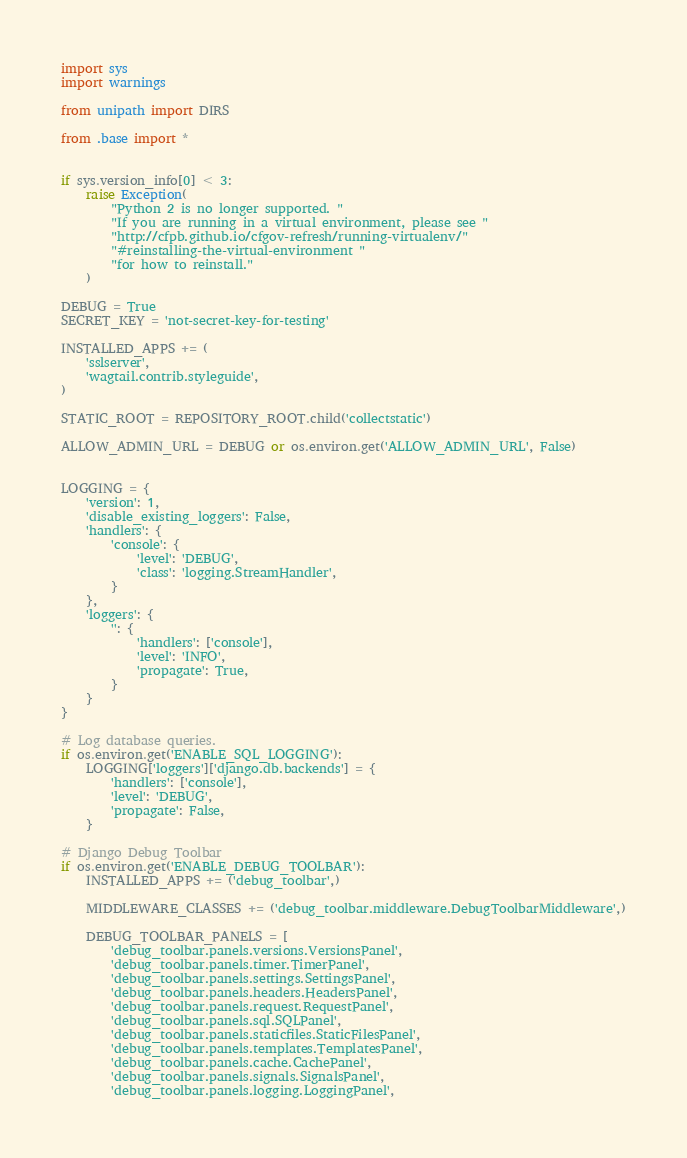Convert code to text. <code><loc_0><loc_0><loc_500><loc_500><_Python_>import sys
import warnings

from unipath import DIRS

from .base import *


if sys.version_info[0] < 3:
    raise Exception(
        "Python 2 is no longer supported. "
        "If you are running in a virtual environment, please see "
        "http://cfpb.github.io/cfgov-refresh/running-virtualenv/"
        "#reinstalling-the-virtual-environment "
        "for how to reinstall."
    )

DEBUG = True
SECRET_KEY = 'not-secret-key-for-testing'

INSTALLED_APPS += (
    'sslserver',
    'wagtail.contrib.styleguide',
)

STATIC_ROOT = REPOSITORY_ROOT.child('collectstatic')

ALLOW_ADMIN_URL = DEBUG or os.environ.get('ALLOW_ADMIN_URL', False)


LOGGING = {
    'version': 1,
    'disable_existing_loggers': False,
    'handlers': {
        'console': {
            'level': 'DEBUG',
            'class': 'logging.StreamHandler',
        }
    },
    'loggers': {
        '': {
            'handlers': ['console'],
            'level': 'INFO',
            'propagate': True,
        }
    }
}

# Log database queries.
if os.environ.get('ENABLE_SQL_LOGGING'):
    LOGGING['loggers']['django.db.backends'] = {
        'handlers': ['console'],
        'level': 'DEBUG',
        'propagate': False,
    }

# Django Debug Toolbar
if os.environ.get('ENABLE_DEBUG_TOOLBAR'):
    INSTALLED_APPS += ('debug_toolbar',)

    MIDDLEWARE_CLASSES += ('debug_toolbar.middleware.DebugToolbarMiddleware',)

    DEBUG_TOOLBAR_PANELS = [
        'debug_toolbar.panels.versions.VersionsPanel',
        'debug_toolbar.panels.timer.TimerPanel',
        'debug_toolbar.panels.settings.SettingsPanel',
        'debug_toolbar.panels.headers.HeadersPanel',
        'debug_toolbar.panels.request.RequestPanel',
        'debug_toolbar.panels.sql.SQLPanel',
        'debug_toolbar.panels.staticfiles.StaticFilesPanel',
        'debug_toolbar.panels.templates.TemplatesPanel',
        'debug_toolbar.panels.cache.CachePanel',
        'debug_toolbar.panels.signals.SignalsPanel',
        'debug_toolbar.panels.logging.LoggingPanel',</code> 